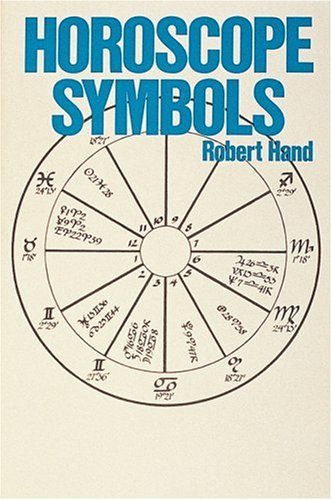Is this a religious book? While not strictly religious, 'Horoscope Symbols' deals with astrology, which some may intertwine with their spiritual beliefs. It provides a scholarly look at symbols used in astrology, not religious practice. 